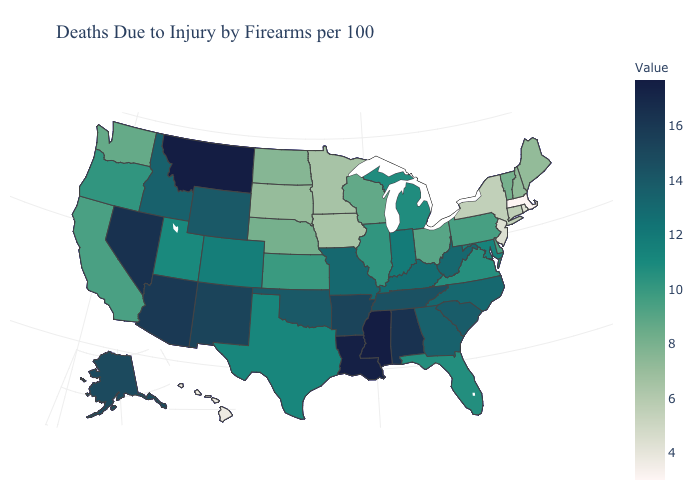Does Massachusetts have the lowest value in the USA?
Be succinct. Yes. Which states have the lowest value in the USA?
Concise answer only. Massachusetts. Does Mississippi have the highest value in the USA?
Keep it brief. Yes. Does Maine have a lower value than Massachusetts?
Quick response, please. No. Among the states that border Oregon , which have the highest value?
Answer briefly. Nevada. Among the states that border Iowa , does Minnesota have the highest value?
Answer briefly. No. 